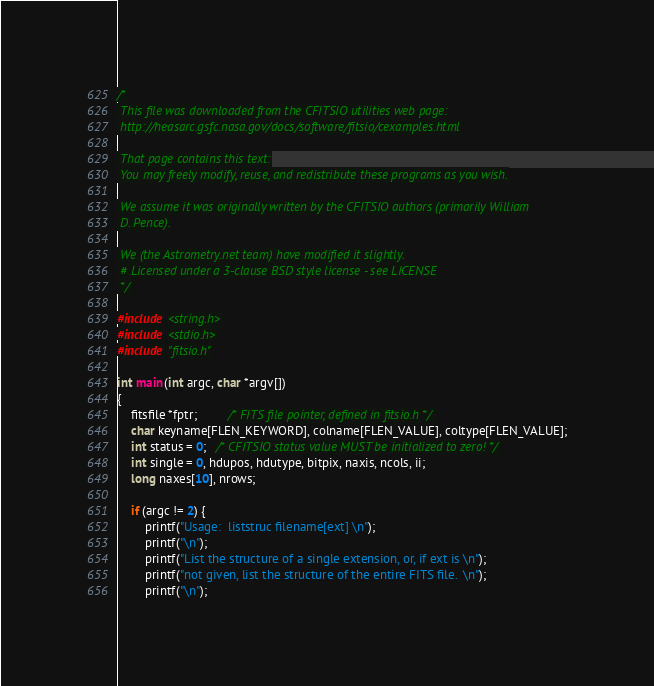Convert code to text. <code><loc_0><loc_0><loc_500><loc_500><_C_>/*
 This file was downloaded from the CFITSIO utilities web page:
 http://heasarc.gsfc.nasa.gov/docs/software/fitsio/cexamples.html

 That page contains this text:
 You may freely modify, reuse, and redistribute these programs as you wish.

 We assume it was originally written by the CFITSIO authors (primarily William
 D. Pence).

 We (the Astrometry.net team) have modified it slightly.
 # Licensed under a 3-clause BSD style license - see LICENSE
 */

#include <string.h>
#include <stdio.h>
#include "fitsio.h"

int main(int argc, char *argv[])
{
    fitsfile *fptr;         /* FITS file pointer, defined in fitsio.h */
    char keyname[FLEN_KEYWORD], colname[FLEN_VALUE], coltype[FLEN_VALUE];
    int status = 0;   /* CFITSIO status value MUST be initialized to zero! */
    int single = 0, hdupos, hdutype, bitpix, naxis, ncols, ii;
    long naxes[10], nrows;

    if (argc != 2) {
        printf("Usage:  liststruc filename[ext] \n");
        printf("\n");
        printf("List the structure of a single extension, or, if ext is \n");
        printf("not given, list the structure of the entire FITS file.  \n");
        printf("\n");</code> 